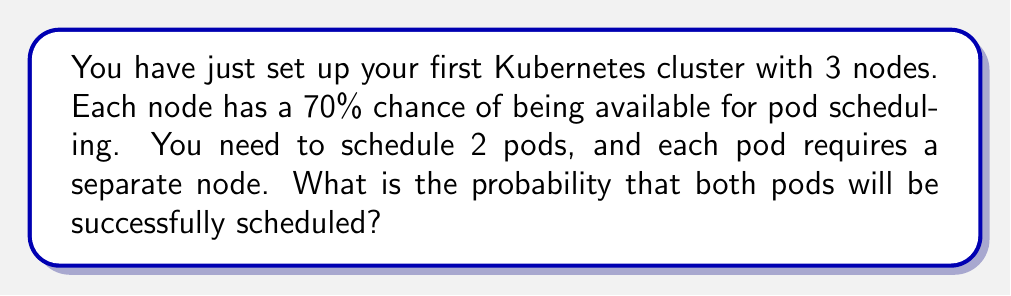Can you solve this math problem? Let's approach this step-by-step:

1) First, we need to calculate the probability of having at least 2 nodes available out of 3.

2) The probability of a node being available is 0.7, and unavailable is 0.3.

3) We can use the binomial probability formula to calculate this:

   $$P(X \geq 2) = P(X = 2) + P(X = 3)$$

   Where $X$ is the number of available nodes.

4) Calculating $P(X = 2)$:
   $$P(X = 2) = \binom{3}{2} \cdot 0.7^2 \cdot 0.3^1 = 3 \cdot 0.49 \cdot 0.3 = 0.441$$

5) Calculating $P(X = 3)$:
   $$P(X = 3) = \binom{3}{3} \cdot 0.7^3 = 0.343$$

6) Therefore, the probability of having at least 2 nodes available is:
   $$P(X \geq 2) = 0.441 + 0.343 = 0.784$$

7) However, this is not our final answer. We need to consider the probability of successfully scheduling both pods given that at least 2 nodes are available.

8) If exactly 2 nodes are available (probability 0.441), there's only one way to schedule 2 pods, so the probability is 1.

9) If all 3 nodes are available (probability 0.343), we have $\binom{3}{2} = 3$ ways to choose 2 nodes out of 3, so the probability is also 1.

10) Therefore, the final probability is:

    $$0.784 \cdot 1 = 0.784$$
Answer: 0.784 or 78.4% 